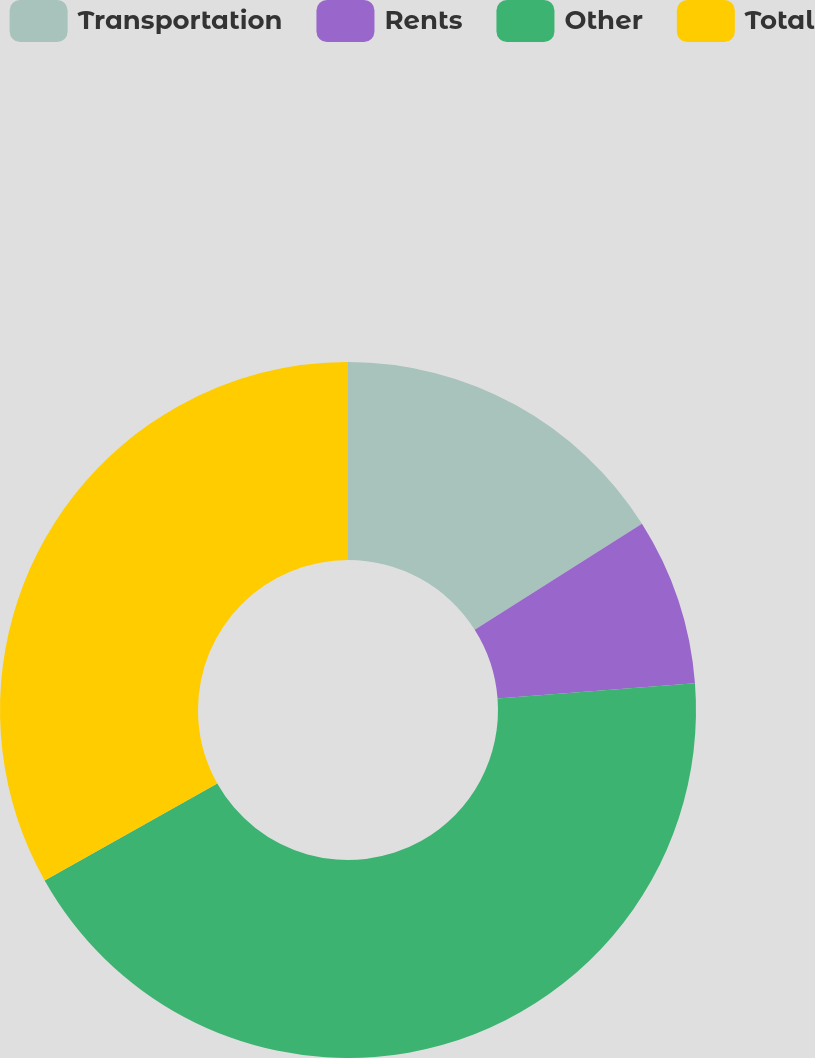<chart> <loc_0><loc_0><loc_500><loc_500><pie_chart><fcel>Transportation<fcel>Rents<fcel>Other<fcel>Total<nl><fcel>16.01%<fcel>7.76%<fcel>43.07%<fcel>33.15%<nl></chart> 